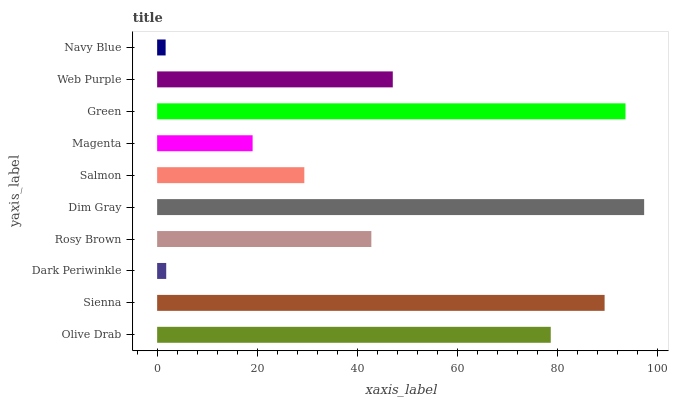Is Navy Blue the minimum?
Answer yes or no. Yes. Is Dim Gray the maximum?
Answer yes or no. Yes. Is Sienna the minimum?
Answer yes or no. No. Is Sienna the maximum?
Answer yes or no. No. Is Sienna greater than Olive Drab?
Answer yes or no. Yes. Is Olive Drab less than Sienna?
Answer yes or no. Yes. Is Olive Drab greater than Sienna?
Answer yes or no. No. Is Sienna less than Olive Drab?
Answer yes or no. No. Is Web Purple the high median?
Answer yes or no. Yes. Is Rosy Brown the low median?
Answer yes or no. Yes. Is Green the high median?
Answer yes or no. No. Is Magenta the low median?
Answer yes or no. No. 